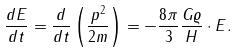<formula> <loc_0><loc_0><loc_500><loc_500>\frac { d E } { d t } = \frac { d } { d t } \left ( \frac { p ^ { 2 } } { 2 m } \right ) = - \frac { 8 \pi } { 3 } \frac { G \varrho } { H } \cdot E .</formula> 